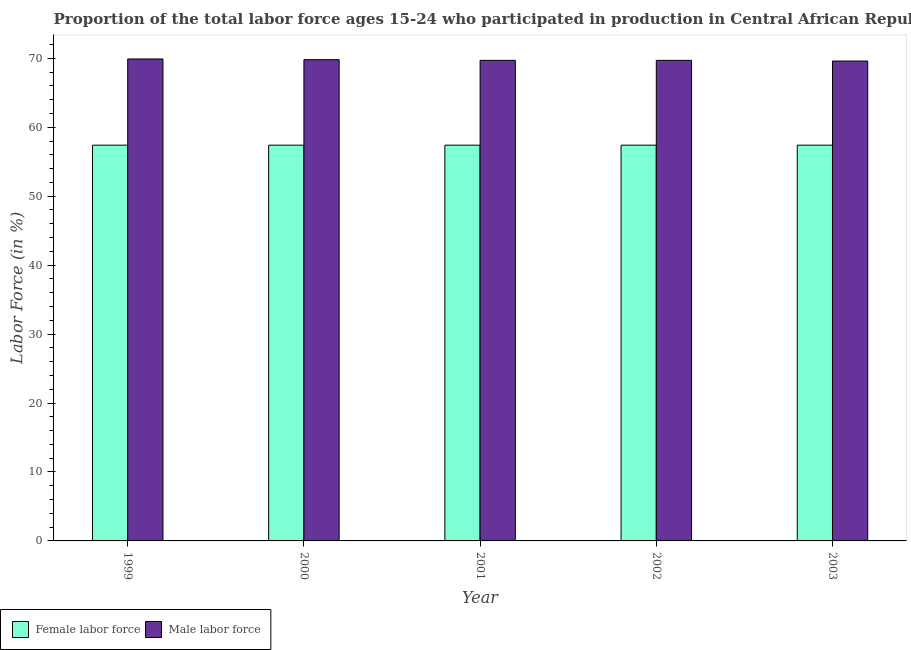How many groups of bars are there?
Your answer should be compact. 5. Are the number of bars on each tick of the X-axis equal?
Your answer should be very brief. Yes. What is the percentage of male labour force in 1999?
Offer a very short reply. 69.9. Across all years, what is the maximum percentage of female labor force?
Keep it short and to the point. 57.4. Across all years, what is the minimum percentage of female labor force?
Provide a short and direct response. 57.4. In which year was the percentage of male labour force maximum?
Offer a terse response. 1999. What is the total percentage of male labour force in the graph?
Offer a terse response. 348.7. What is the difference between the percentage of male labour force in 1999 and that in 2002?
Offer a very short reply. 0.2. What is the difference between the percentage of female labor force in 1999 and the percentage of male labour force in 2002?
Offer a terse response. 0. What is the average percentage of male labour force per year?
Provide a succinct answer. 69.74. In how many years, is the percentage of male labour force greater than 62 %?
Provide a succinct answer. 5. What is the ratio of the percentage of male labour force in 2000 to that in 2001?
Offer a very short reply. 1. Is the percentage of male labour force in 2002 less than that in 2003?
Provide a short and direct response. No. Is the difference between the percentage of male labour force in 1999 and 2003 greater than the difference between the percentage of female labor force in 1999 and 2003?
Offer a very short reply. No. What is the difference between the highest and the second highest percentage of female labor force?
Provide a succinct answer. 0. What is the difference between the highest and the lowest percentage of female labor force?
Give a very brief answer. 0. In how many years, is the percentage of male labour force greater than the average percentage of male labour force taken over all years?
Your answer should be compact. 2. What does the 2nd bar from the left in 2001 represents?
Ensure brevity in your answer.  Male labor force. What does the 1st bar from the right in 2003 represents?
Provide a succinct answer. Male labor force. Does the graph contain any zero values?
Ensure brevity in your answer.  No. Does the graph contain grids?
Your response must be concise. No. How many legend labels are there?
Your answer should be very brief. 2. What is the title of the graph?
Offer a terse response. Proportion of the total labor force ages 15-24 who participated in production in Central African Republic. What is the label or title of the X-axis?
Your answer should be compact. Year. What is the label or title of the Y-axis?
Provide a short and direct response. Labor Force (in %). What is the Labor Force (in %) of Female labor force in 1999?
Give a very brief answer. 57.4. What is the Labor Force (in %) in Male labor force in 1999?
Make the answer very short. 69.9. What is the Labor Force (in %) of Female labor force in 2000?
Provide a succinct answer. 57.4. What is the Labor Force (in %) of Male labor force in 2000?
Offer a very short reply. 69.8. What is the Labor Force (in %) in Female labor force in 2001?
Provide a short and direct response. 57.4. What is the Labor Force (in %) of Male labor force in 2001?
Give a very brief answer. 69.7. What is the Labor Force (in %) in Female labor force in 2002?
Your response must be concise. 57.4. What is the Labor Force (in %) in Male labor force in 2002?
Your answer should be compact. 69.7. What is the Labor Force (in %) of Female labor force in 2003?
Provide a succinct answer. 57.4. What is the Labor Force (in %) of Male labor force in 2003?
Provide a succinct answer. 69.6. Across all years, what is the maximum Labor Force (in %) in Female labor force?
Ensure brevity in your answer.  57.4. Across all years, what is the maximum Labor Force (in %) of Male labor force?
Provide a short and direct response. 69.9. Across all years, what is the minimum Labor Force (in %) in Female labor force?
Offer a very short reply. 57.4. Across all years, what is the minimum Labor Force (in %) in Male labor force?
Your answer should be very brief. 69.6. What is the total Labor Force (in %) in Female labor force in the graph?
Provide a short and direct response. 287. What is the total Labor Force (in %) in Male labor force in the graph?
Provide a short and direct response. 348.7. What is the difference between the Labor Force (in %) of Male labor force in 1999 and that in 2000?
Ensure brevity in your answer.  0.1. What is the difference between the Labor Force (in %) of Female labor force in 1999 and that in 2001?
Provide a short and direct response. 0. What is the difference between the Labor Force (in %) of Male labor force in 1999 and that in 2001?
Give a very brief answer. 0.2. What is the difference between the Labor Force (in %) of Female labor force in 1999 and that in 2002?
Offer a very short reply. 0. What is the difference between the Labor Force (in %) of Female labor force in 1999 and that in 2003?
Offer a very short reply. 0. What is the difference between the Labor Force (in %) of Male labor force in 2000 and that in 2001?
Keep it short and to the point. 0.1. What is the difference between the Labor Force (in %) of Female labor force in 2000 and that in 2002?
Your response must be concise. 0. What is the difference between the Labor Force (in %) of Male labor force in 2000 and that in 2002?
Offer a very short reply. 0.1. What is the difference between the Labor Force (in %) of Female labor force in 2001 and that in 2002?
Your response must be concise. 0. What is the difference between the Labor Force (in %) in Male labor force in 2001 and that in 2002?
Provide a short and direct response. 0. What is the difference between the Labor Force (in %) in Female labor force in 1999 and the Labor Force (in %) in Male labor force in 2002?
Make the answer very short. -12.3. What is the difference between the Labor Force (in %) in Female labor force in 2000 and the Labor Force (in %) in Male labor force in 2003?
Keep it short and to the point. -12.2. What is the difference between the Labor Force (in %) in Female labor force in 2001 and the Labor Force (in %) in Male labor force in 2002?
Make the answer very short. -12.3. What is the difference between the Labor Force (in %) of Female labor force in 2001 and the Labor Force (in %) of Male labor force in 2003?
Your answer should be compact. -12.2. What is the average Labor Force (in %) of Female labor force per year?
Make the answer very short. 57.4. What is the average Labor Force (in %) of Male labor force per year?
Keep it short and to the point. 69.74. In the year 1999, what is the difference between the Labor Force (in %) in Female labor force and Labor Force (in %) in Male labor force?
Offer a terse response. -12.5. In the year 2001, what is the difference between the Labor Force (in %) in Female labor force and Labor Force (in %) in Male labor force?
Your response must be concise. -12.3. What is the ratio of the Labor Force (in %) in Female labor force in 1999 to that in 2000?
Your answer should be compact. 1. What is the ratio of the Labor Force (in %) of Male labor force in 1999 to that in 2000?
Your answer should be compact. 1. What is the ratio of the Labor Force (in %) in Female labor force in 1999 to that in 2002?
Your response must be concise. 1. What is the ratio of the Labor Force (in %) of Male labor force in 1999 to that in 2002?
Ensure brevity in your answer.  1. What is the ratio of the Labor Force (in %) in Female labor force in 1999 to that in 2003?
Your answer should be compact. 1. What is the ratio of the Labor Force (in %) of Male labor force in 1999 to that in 2003?
Give a very brief answer. 1. What is the ratio of the Labor Force (in %) in Male labor force in 2000 to that in 2001?
Offer a very short reply. 1. What is the ratio of the Labor Force (in %) of Female labor force in 2000 to that in 2002?
Offer a terse response. 1. What is the ratio of the Labor Force (in %) of Male labor force in 2000 to that in 2003?
Your answer should be very brief. 1. What is the ratio of the Labor Force (in %) in Male labor force in 2002 to that in 2003?
Provide a short and direct response. 1. What is the difference between the highest and the second highest Labor Force (in %) of Female labor force?
Offer a very short reply. 0. What is the difference between the highest and the lowest Labor Force (in %) of Female labor force?
Offer a terse response. 0. 